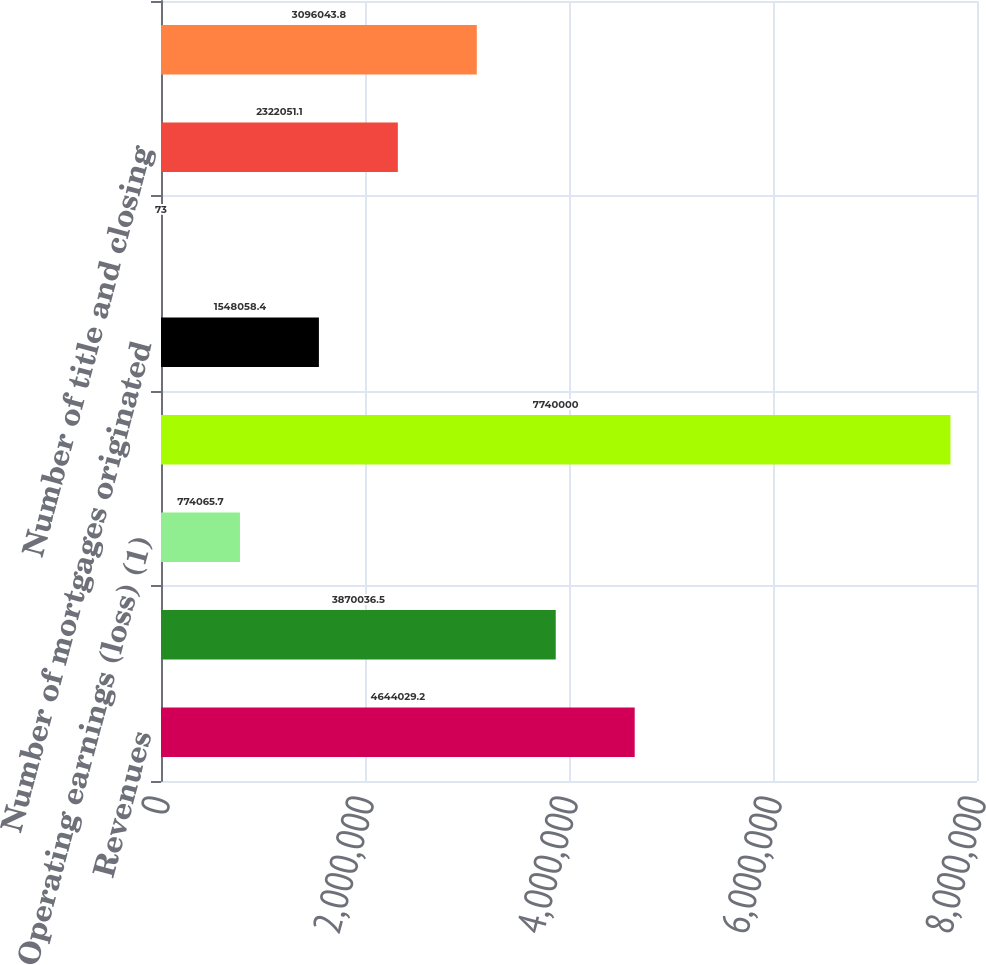Convert chart. <chart><loc_0><loc_0><loc_500><loc_500><bar_chart><fcel>Revenues<fcel>Costs and expenses (1)<fcel>Operating earnings (loss) (1)<fcel>Dollar value of mortgages<fcel>Number of mortgages originated<fcel>Mortgage capture rate of<fcel>Number of title and closing<fcel>Number of title policies<nl><fcel>4.64403e+06<fcel>3.87004e+06<fcel>774066<fcel>7.74e+06<fcel>1.54806e+06<fcel>73<fcel>2.32205e+06<fcel>3.09604e+06<nl></chart> 